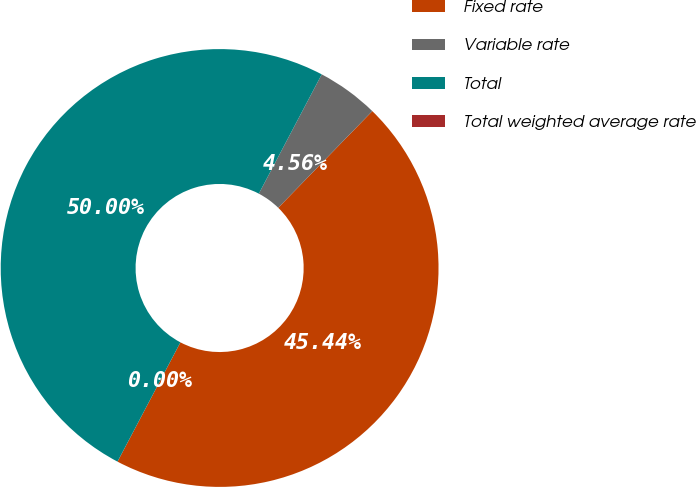Convert chart. <chart><loc_0><loc_0><loc_500><loc_500><pie_chart><fcel>Fixed rate<fcel>Variable rate<fcel>Total<fcel>Total weighted average rate<nl><fcel>45.44%<fcel>4.56%<fcel>50.0%<fcel>0.0%<nl></chart> 